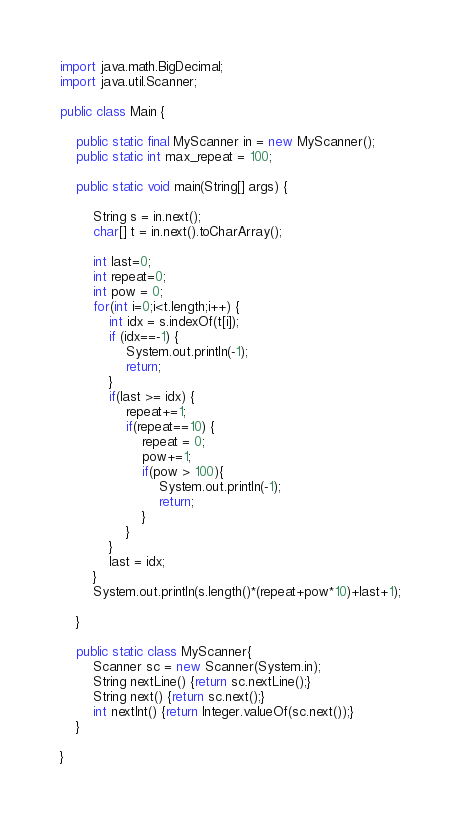Convert code to text. <code><loc_0><loc_0><loc_500><loc_500><_Java_>import java.math.BigDecimal;
import java.util.Scanner;
 
public class Main {

	public static final MyScanner in = new MyScanner();
	public static int max_repeat = 100;

	public static void main(String[] args) {

		String s = in.next();
		char[] t = in.next().toCharArray();

		int last=0;
		int repeat=0;
		int pow = 0;
		for(int i=0;i<t.length;i++) {
			int idx = s.indexOf(t[i]);
			if (idx==-1) {
				System.out.println(-1);
				return;
			}
			if(last >= idx) {
				repeat+=1;
				if(repeat==10) {
					repeat = 0;
					pow+=1;
					if(pow > 100){
						System.out.println(-1);
						return;
					}
				}
			}
			last = idx;
		}
		System.out.println(s.length()*(repeat+pow*10)+last+1);

	}

	public static class MyScanner{
		Scanner sc = new Scanner(System.in);
		String nextLine() {return sc.nextLine();}
		String next() {return sc.next();}
		int nextInt() {return Integer.valueOf(sc.next());}
	}

}</code> 